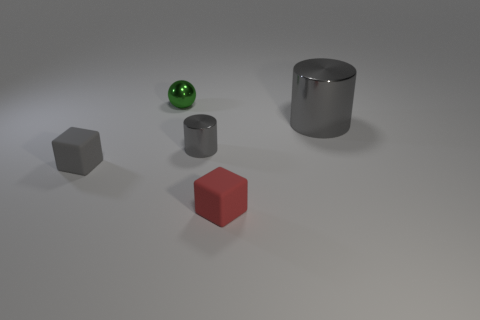Add 5 small brown cylinders. How many objects exist? 10 Subtract all balls. How many objects are left? 4 Add 2 small cyan rubber balls. How many small cyan rubber balls exist? 2 Subtract 0 cyan cubes. How many objects are left? 5 Subtract all large gray shiny cylinders. Subtract all green metallic balls. How many objects are left? 3 Add 1 gray rubber objects. How many gray rubber objects are left? 2 